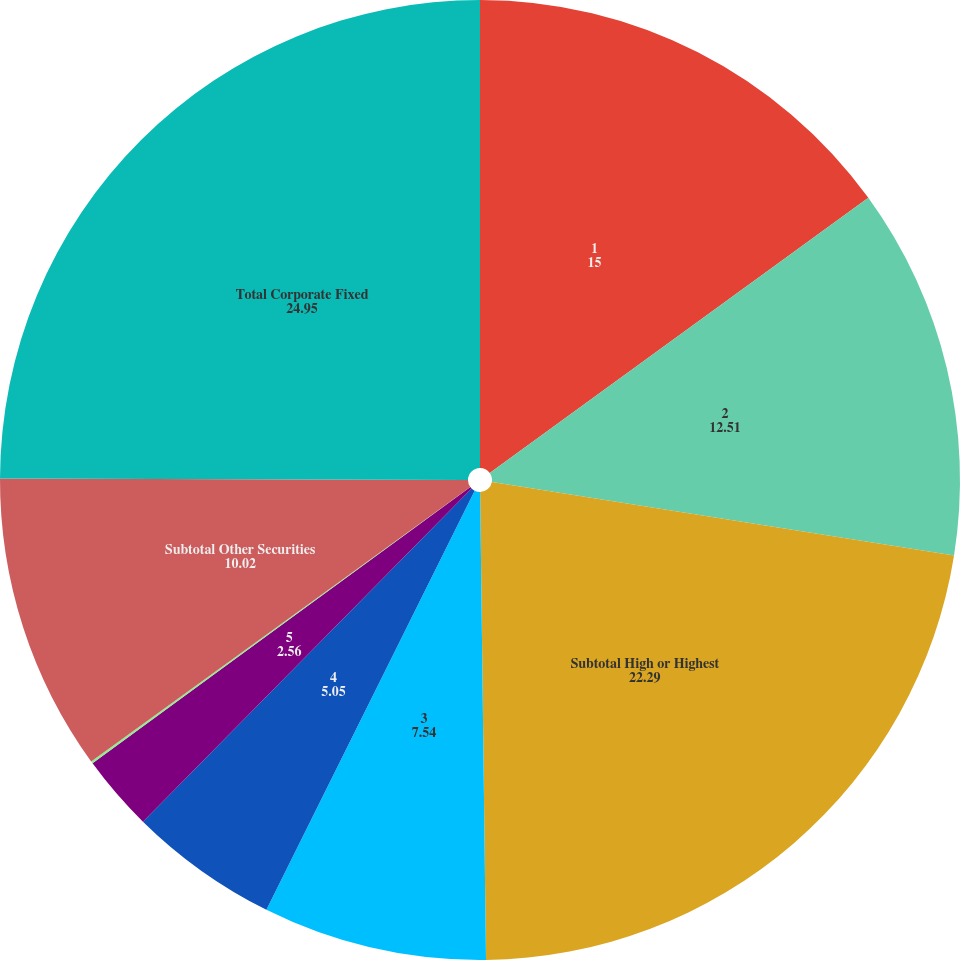<chart> <loc_0><loc_0><loc_500><loc_500><pie_chart><fcel>1<fcel>2<fcel>Subtotal High or Highest<fcel>3<fcel>4<fcel>5<fcel>6<fcel>Subtotal Other Securities<fcel>Total Corporate Fixed<nl><fcel>15.0%<fcel>12.51%<fcel>22.29%<fcel>7.54%<fcel>5.05%<fcel>2.56%<fcel>0.08%<fcel>10.02%<fcel>24.95%<nl></chart> 